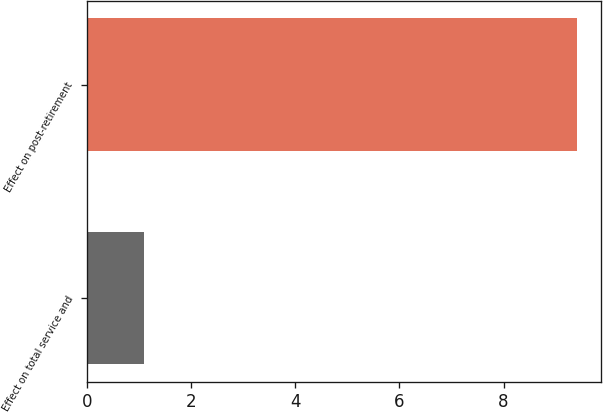<chart> <loc_0><loc_0><loc_500><loc_500><bar_chart><fcel>Effect on total service and<fcel>Effect on post-retirement<nl><fcel>1.1<fcel>9.4<nl></chart> 